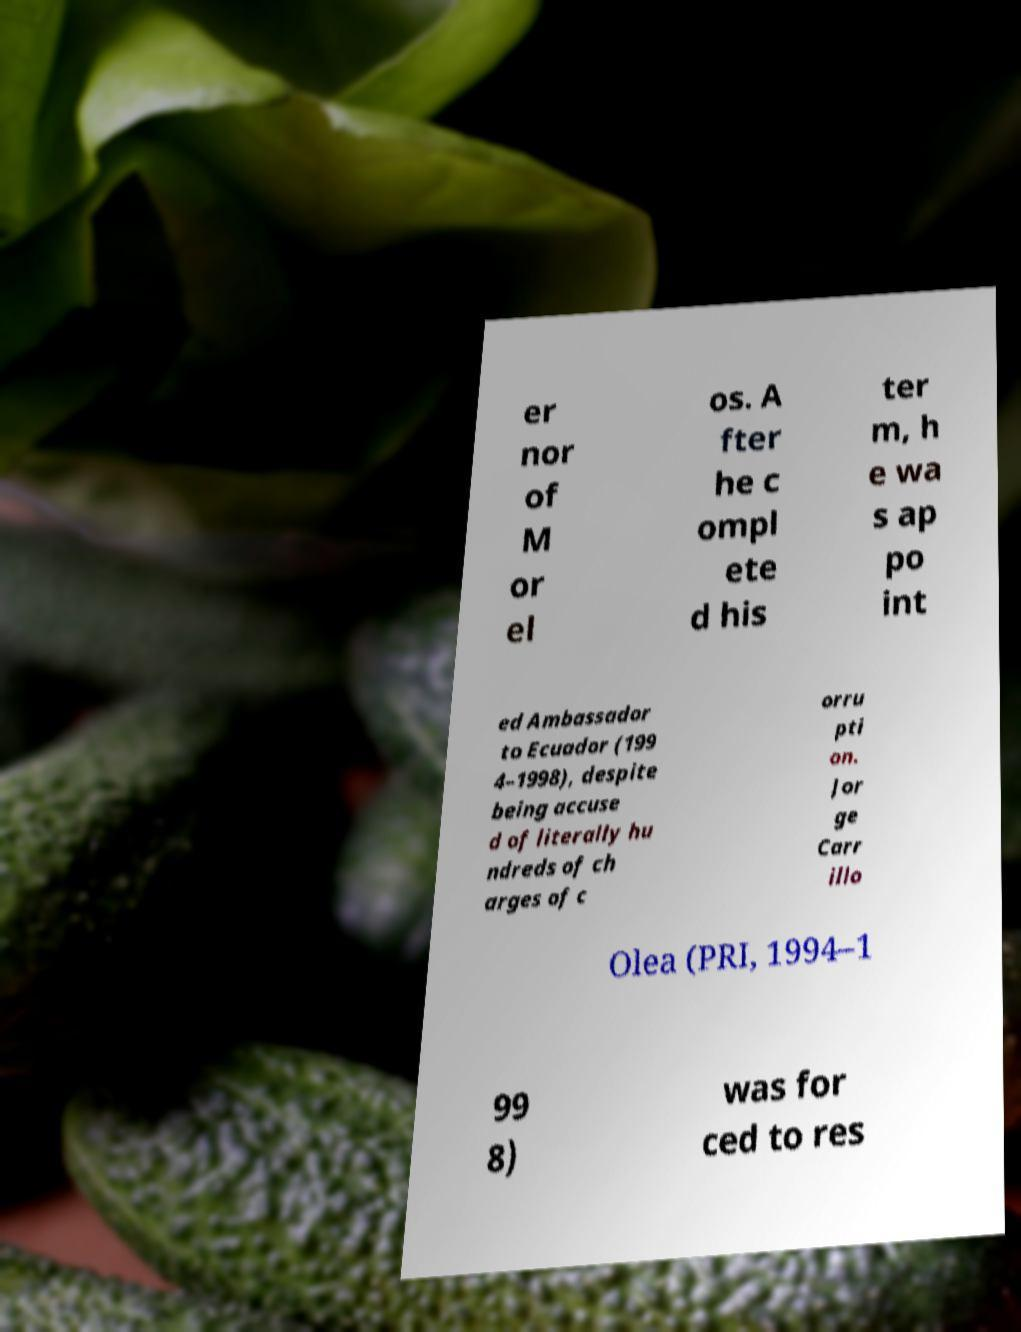What messages or text are displayed in this image? I need them in a readable, typed format. er nor of M or el os. A fter he c ompl ete d his ter m, h e wa s ap po int ed Ambassador to Ecuador (199 4–1998), despite being accuse d of literally hu ndreds of ch arges of c orru pti on. Jor ge Carr illo Olea (PRI, 1994–1 99 8) was for ced to res 